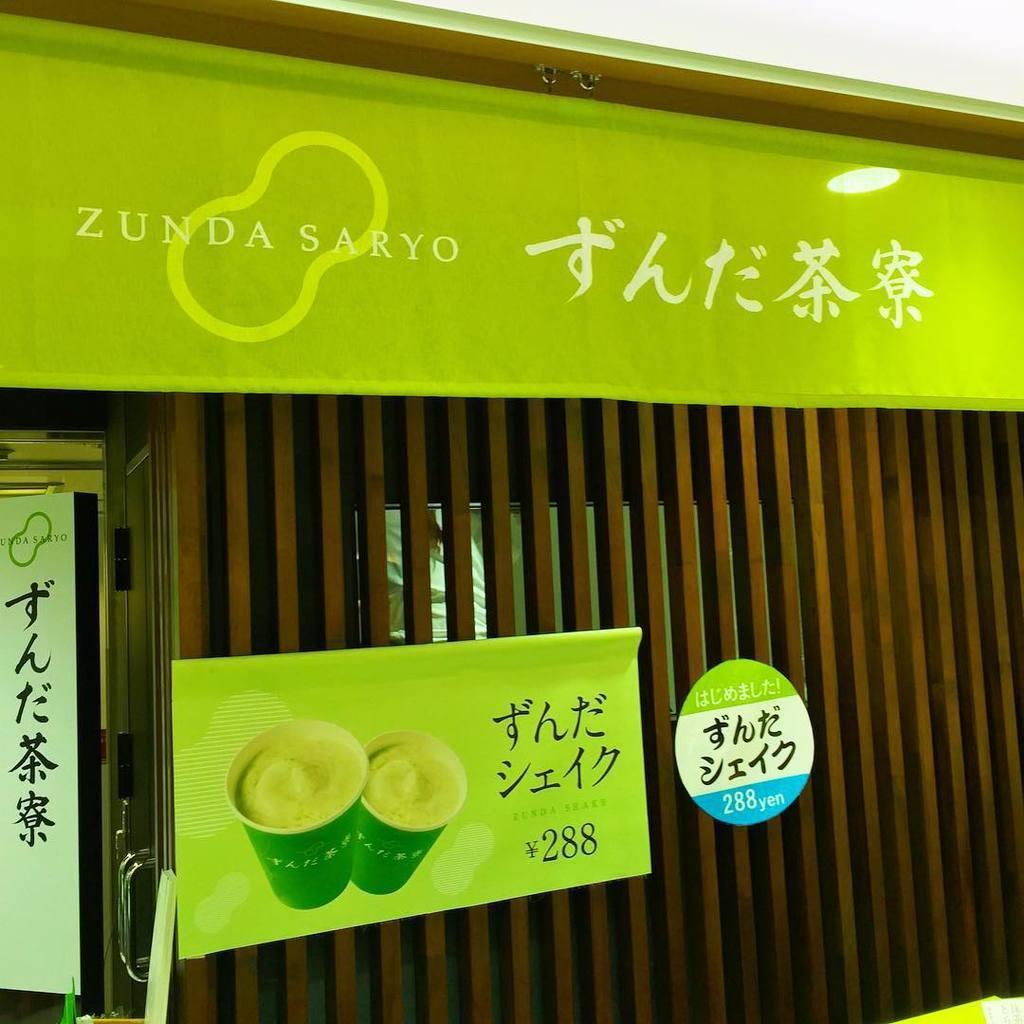Please provide a concise description of this image. On this wooden grill there we can hoardings and sticker. On this banner we can see cups. 